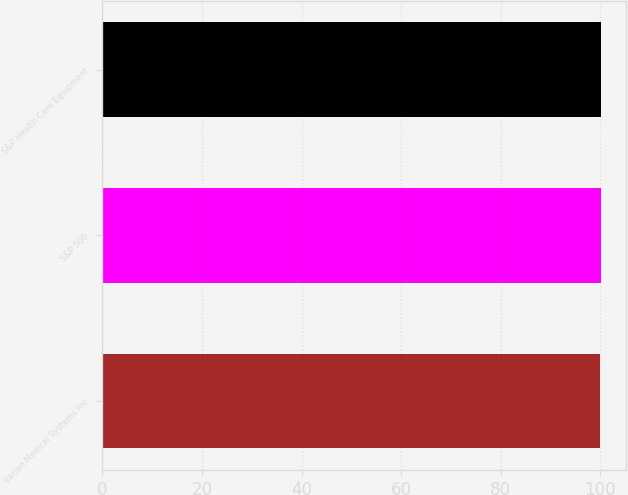Convert chart. <chart><loc_0><loc_0><loc_500><loc_500><bar_chart><fcel>Varian Medical Systems Inc<fcel>S&P 500<fcel>S&P Health Care Equipment<nl><fcel>100<fcel>100.1<fcel>100.2<nl></chart> 